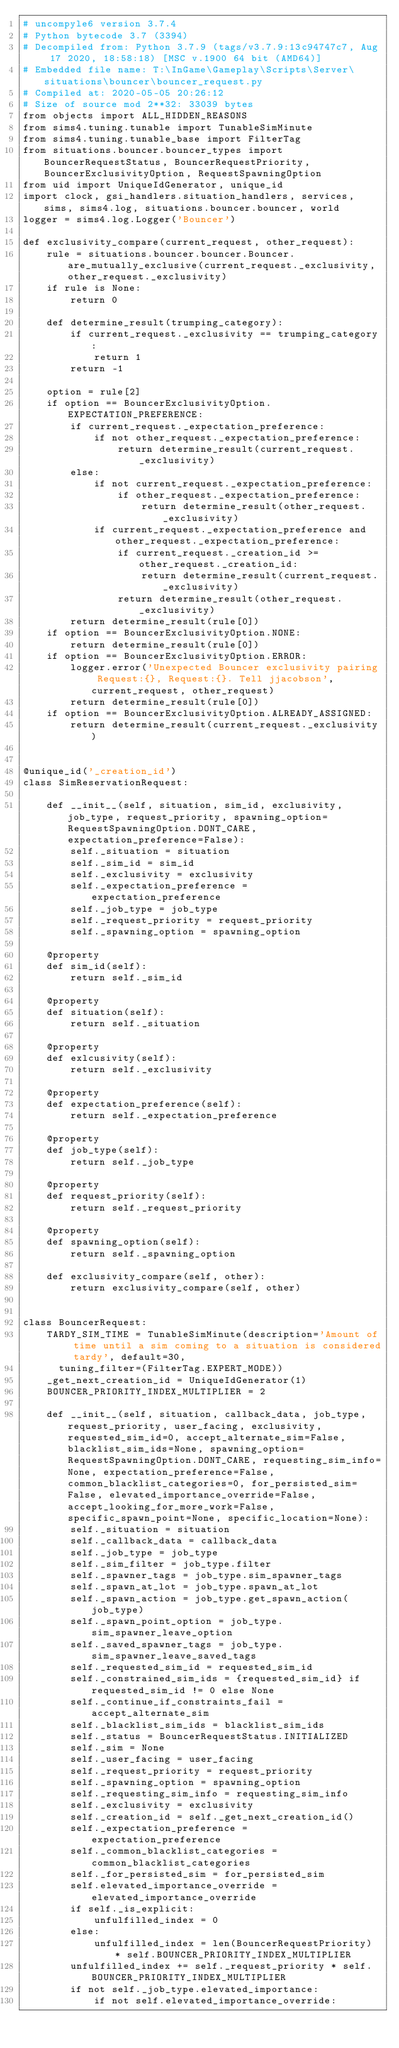<code> <loc_0><loc_0><loc_500><loc_500><_Python_># uncompyle6 version 3.7.4
# Python bytecode 3.7 (3394)
# Decompiled from: Python 3.7.9 (tags/v3.7.9:13c94747c7, Aug 17 2020, 18:58:18) [MSC v.1900 64 bit (AMD64)]
# Embedded file name: T:\InGame\Gameplay\Scripts\Server\situations\bouncer\bouncer_request.py
# Compiled at: 2020-05-05 20:26:12
# Size of source mod 2**32: 33039 bytes
from objects import ALL_HIDDEN_REASONS
from sims4.tuning.tunable import TunableSimMinute
from sims4.tuning.tunable_base import FilterTag
from situations.bouncer.bouncer_types import BouncerRequestStatus, BouncerRequestPriority, BouncerExclusivityOption, RequestSpawningOption
from uid import UniqueIdGenerator, unique_id
import clock, gsi_handlers.situation_handlers, services, sims, sims4.log, situations.bouncer.bouncer, world
logger = sims4.log.Logger('Bouncer')

def exclusivity_compare(current_request, other_request):
    rule = situations.bouncer.bouncer.Bouncer.are_mutually_exclusive(current_request._exclusivity, other_request._exclusivity)
    if rule is None:
        return 0

    def determine_result(trumping_category):
        if current_request._exclusivity == trumping_category:
            return 1
        return -1

    option = rule[2]
    if option == BouncerExclusivityOption.EXPECTATION_PREFERENCE:
        if current_request._expectation_preference:
            if not other_request._expectation_preference:
                return determine_result(current_request._exclusivity)
        else:
            if not current_request._expectation_preference:
                if other_request._expectation_preference:
                    return determine_result(other_request._exclusivity)
            if current_request._expectation_preference and other_request._expectation_preference:
                if current_request._creation_id >= other_request._creation_id:
                    return determine_result(current_request._exclusivity)
                return determine_result(other_request._exclusivity)
        return determine_result(rule[0])
    if option == BouncerExclusivityOption.NONE:
        return determine_result(rule[0])
    if option == BouncerExclusivityOption.ERROR:
        logger.error('Unexpected Bouncer exclusivity pairing Request:{}, Request:{}. Tell jjacobson', current_request, other_request)
        return determine_result(rule[0])
    if option == BouncerExclusivityOption.ALREADY_ASSIGNED:
        return determine_result(current_request._exclusivity)


@unique_id('_creation_id')
class SimReservationRequest:

    def __init__(self, situation, sim_id, exclusivity, job_type, request_priority, spawning_option=RequestSpawningOption.DONT_CARE, expectation_preference=False):
        self._situation = situation
        self._sim_id = sim_id
        self._exclusivity = exclusivity
        self._expectation_preference = expectation_preference
        self._job_type = job_type
        self._request_priority = request_priority
        self._spawning_option = spawning_option

    @property
    def sim_id(self):
        return self._sim_id

    @property
    def situation(self):
        return self._situation

    @property
    def exlcusivity(self):
        return self._exclusivity

    @property
    def expectation_preference(self):
        return self._expectation_preference

    @property
    def job_type(self):
        return self._job_type

    @property
    def request_priority(self):
        return self._request_priority

    @property
    def spawning_option(self):
        return self._spawning_option

    def exclusivity_compare(self, other):
        return exclusivity_compare(self, other)


class BouncerRequest:
    TARDY_SIM_TIME = TunableSimMinute(description='Amount of time until a sim coming to a situation is considered tardy', default=30,
      tuning_filter=(FilterTag.EXPERT_MODE))
    _get_next_creation_id = UniqueIdGenerator(1)
    BOUNCER_PRIORITY_INDEX_MULTIPLIER = 2

    def __init__(self, situation, callback_data, job_type, request_priority, user_facing, exclusivity, requested_sim_id=0, accept_alternate_sim=False, blacklist_sim_ids=None, spawning_option=RequestSpawningOption.DONT_CARE, requesting_sim_info=None, expectation_preference=False, common_blacklist_categories=0, for_persisted_sim=False, elevated_importance_override=False, accept_looking_for_more_work=False, specific_spawn_point=None, specific_location=None):
        self._situation = situation
        self._callback_data = callback_data
        self._job_type = job_type
        self._sim_filter = job_type.filter
        self._spawner_tags = job_type.sim_spawner_tags
        self._spawn_at_lot = job_type.spawn_at_lot
        self._spawn_action = job_type.get_spawn_action(job_type)
        self._spawn_point_option = job_type.sim_spawner_leave_option
        self._saved_spawner_tags = job_type.sim_spawner_leave_saved_tags
        self._requested_sim_id = requested_sim_id
        self._constrained_sim_ids = {requested_sim_id} if requested_sim_id != 0 else None
        self._continue_if_constraints_fail = accept_alternate_sim
        self._blacklist_sim_ids = blacklist_sim_ids
        self._status = BouncerRequestStatus.INITIALIZED
        self._sim = None
        self._user_facing = user_facing
        self._request_priority = request_priority
        self._spawning_option = spawning_option
        self._requesting_sim_info = requesting_sim_info
        self._exclusivity = exclusivity
        self._creation_id = self._get_next_creation_id()
        self._expectation_preference = expectation_preference
        self._common_blacklist_categories = common_blacklist_categories
        self._for_persisted_sim = for_persisted_sim
        self.elevated_importance_override = elevated_importance_override
        if self._is_explicit:
            unfulfilled_index = 0
        else:
            unfulfilled_index = len(BouncerRequestPriority) * self.BOUNCER_PRIORITY_INDEX_MULTIPLIER
        unfulfilled_index += self._request_priority * self.BOUNCER_PRIORITY_INDEX_MULTIPLIER
        if not self._job_type.elevated_importance:
            if not self.elevated_importance_override:</code> 